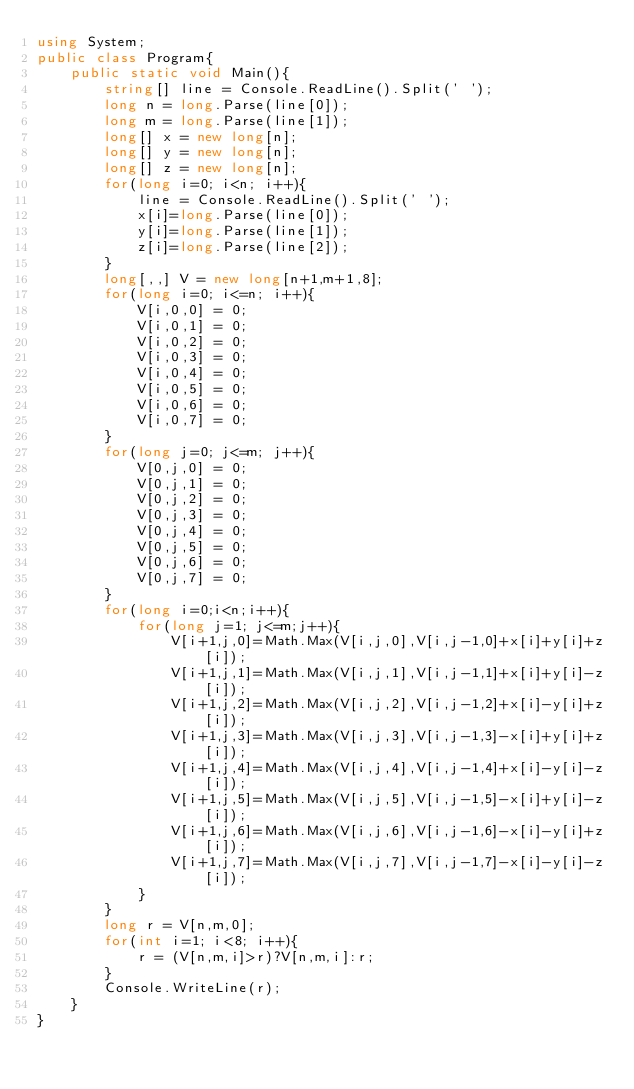<code> <loc_0><loc_0><loc_500><loc_500><_C#_>using System;
public class Program{
    public static void Main(){
        string[] line = Console.ReadLine().Split(' ');
        long n = long.Parse(line[0]);
        long m = long.Parse(line[1]);
        long[] x = new long[n];
        long[] y = new long[n];
        long[] z = new long[n];
        for(long i=0; i<n; i++){
            line = Console.ReadLine().Split(' ');
            x[i]=long.Parse(line[0]);
            y[i]=long.Parse(line[1]);
            z[i]=long.Parse(line[2]);
        } 
        long[,,] V = new long[n+1,m+1,8];
        for(long i=0; i<=n; i++){
            V[i,0,0] = 0;
            V[i,0,1] = 0;
            V[i,0,2] = 0;
            V[i,0,3] = 0;
            V[i,0,4] = 0;
            V[i,0,5] = 0;
            V[i,0,6] = 0;
            V[i,0,7] = 0;
        }
        for(long j=0; j<=m; j++){
            V[0,j,0] = 0;
            V[0,j,1] = 0;
            V[0,j,2] = 0;
            V[0,j,3] = 0;
            V[0,j,4] = 0;
            V[0,j,5] = 0;
            V[0,j,6] = 0;
            V[0,j,7] = 0;
        }
        for(long i=0;i<n;i++){
            for(long j=1; j<=m;j++){
                V[i+1,j,0]=Math.Max(V[i,j,0],V[i,j-1,0]+x[i]+y[i]+z[i]);
                V[i+1,j,1]=Math.Max(V[i,j,1],V[i,j-1,1]+x[i]+y[i]-z[i]);
                V[i+1,j,2]=Math.Max(V[i,j,2],V[i,j-1,2]+x[i]-y[i]+z[i]);
                V[i+1,j,3]=Math.Max(V[i,j,3],V[i,j-1,3]-x[i]+y[i]+z[i]);
                V[i+1,j,4]=Math.Max(V[i,j,4],V[i,j-1,4]+x[i]-y[i]-z[i]);
                V[i+1,j,5]=Math.Max(V[i,j,5],V[i,j-1,5]-x[i]+y[i]-z[i]);
                V[i+1,j,6]=Math.Max(V[i,j,6],V[i,j-1,6]-x[i]-y[i]+z[i]);
                V[i+1,j,7]=Math.Max(V[i,j,7],V[i,j-1,7]-x[i]-y[i]-z[i]);
            }
        }
        long r = V[n,m,0];
        for(int i=1; i<8; i++){
            r = (V[n,m,i]>r)?V[n,m,i]:r;
        }
        Console.WriteLine(r);
    }
}</code> 